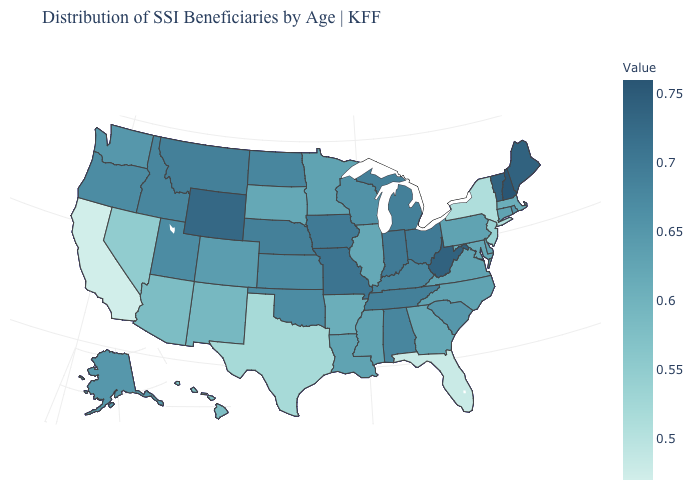Among the states that border Idaho , does Wyoming have the highest value?
Keep it brief. Yes. Which states have the lowest value in the USA?
Be succinct. California. Which states hav the highest value in the Northeast?
Answer briefly. New Hampshire. Which states have the highest value in the USA?
Answer briefly. New Hampshire. 